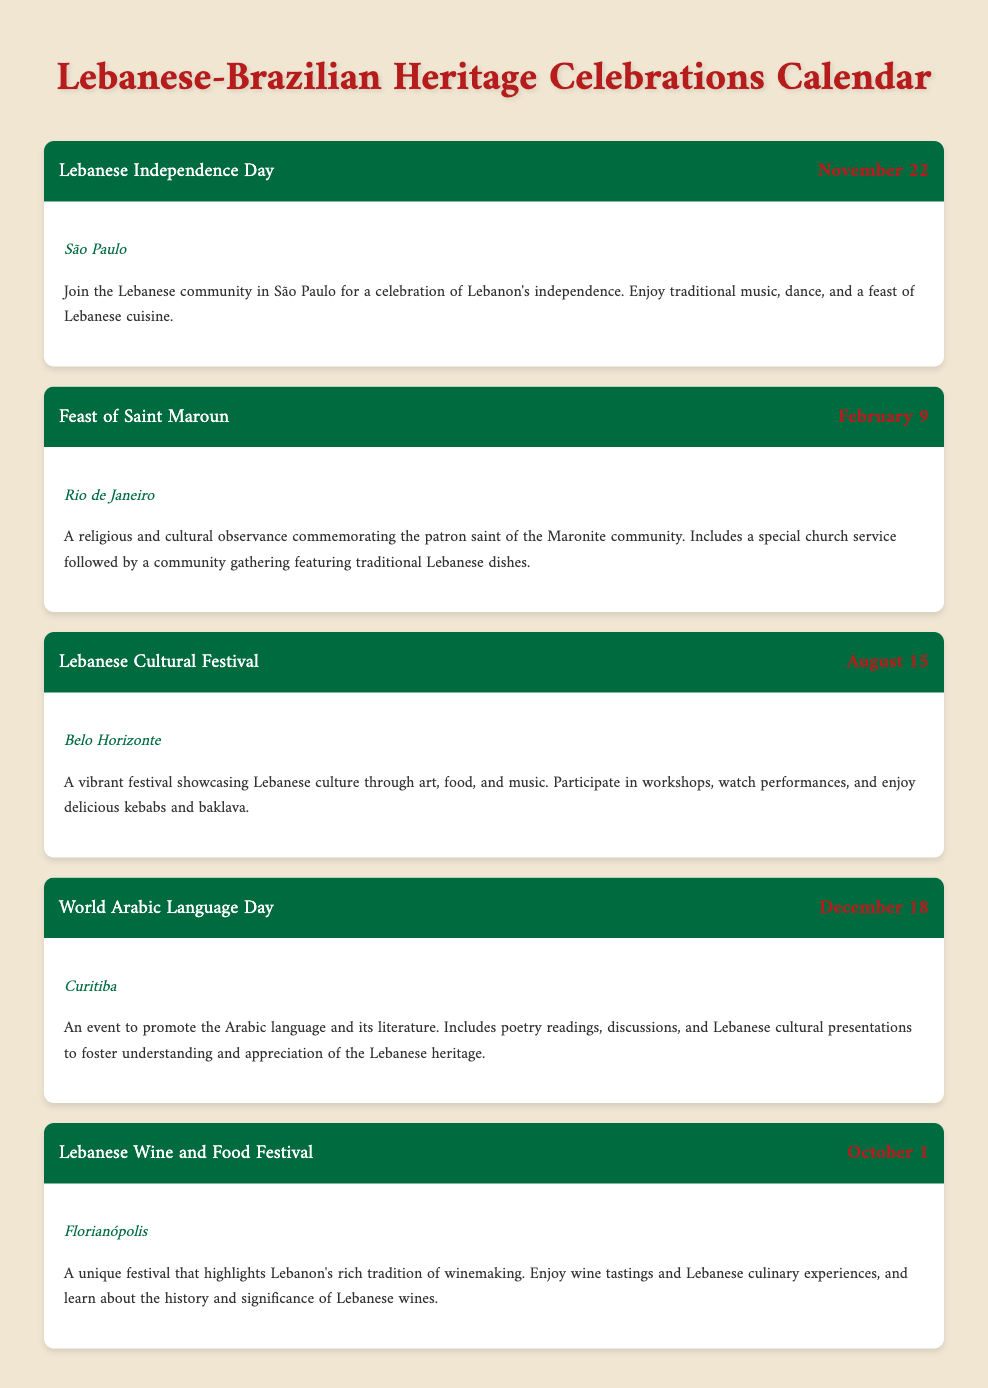What is the first event listed? The first event in the calendar is "Lebanese Independence Day."
Answer: Lebanese Independence Day What is the date of the Feast of Saint Maroun? The Feast of Saint Maroun occurs on February 9.
Answer: February 9 Where is the Lebanese Cultural Festival held? The event takes place in Belo Horizonte.
Answer: Belo Horizonte How many events are listed in the calendar? There are a total of five events mentioned in the document.
Answer: Five What is the main focus of World Arabic Language Day? The main focus is to promote the Arabic language and its literature.
Answer: Promote the Arabic language Which event features wine tastings? The Lebanese Wine and Food Festival includes wine tastings.
Answer: Lebanese Wine and Food Festival What type of event is the Feast of Saint Maroun? It is described as a religious and cultural observance.
Answer: Religious and cultural observance What month is the Lebanese Independence Day celebrated? Lebanese Independence Day is celebrated in November.
Answer: November 